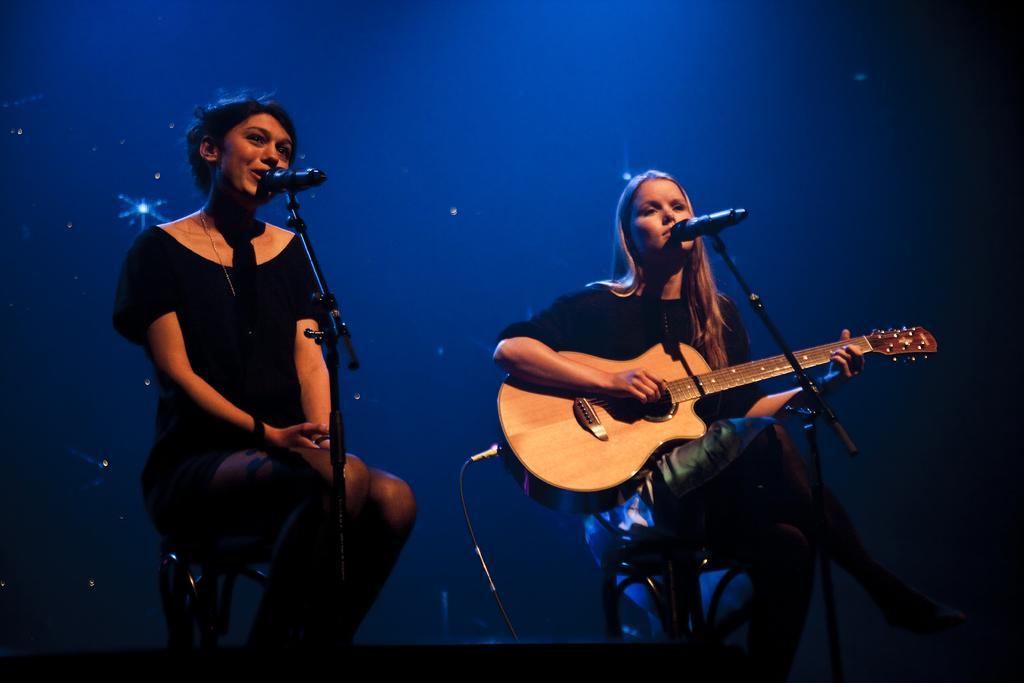Describe this image in one or two sentences. In this image there is a woman sitting in a chair and singing a song in the microphone ,another woman sitting in chair and playing a guitar ,and there is a dark back ground. 